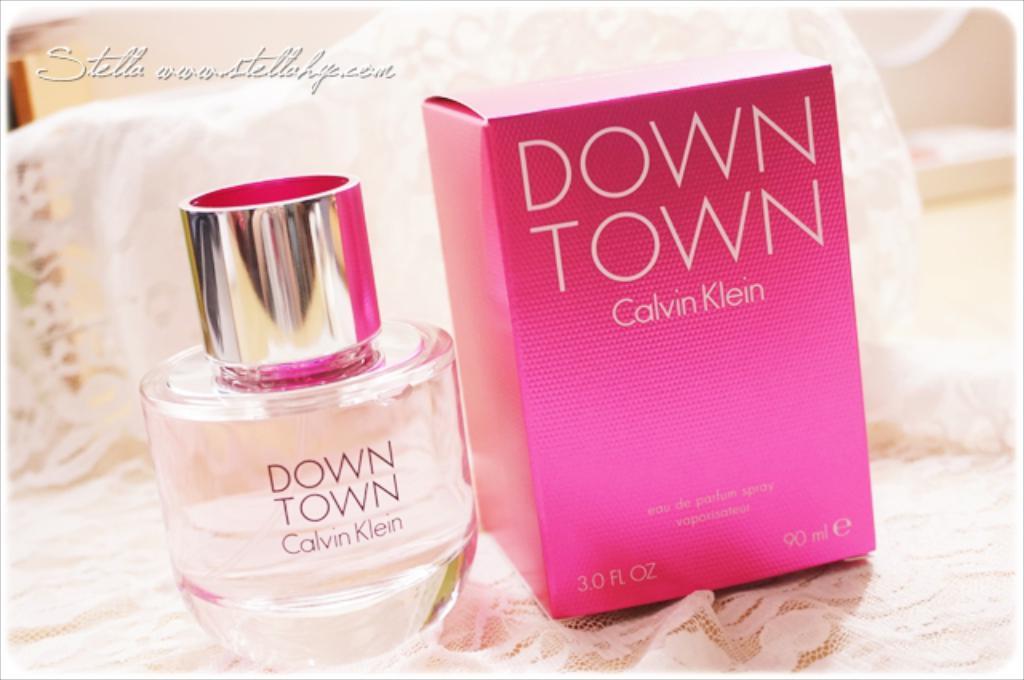What is the name on the box?
Your answer should be very brief. Calvin klein. What is the name of the perfume?
Offer a terse response. Down town. 